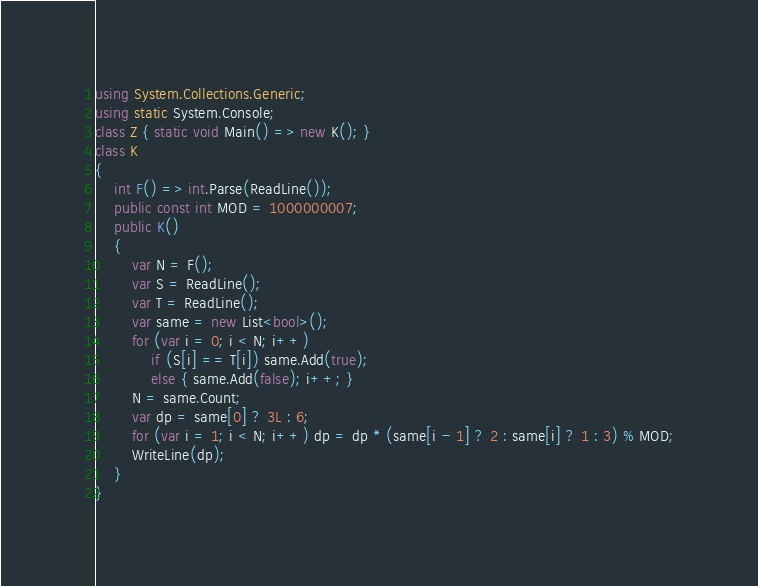<code> <loc_0><loc_0><loc_500><loc_500><_C#_>using System.Collections.Generic;
using static System.Console;
class Z { static void Main() => new K(); }
class K
{
	int F() => int.Parse(ReadLine());
	public const int MOD = 1000000007;
	public K()
	{
		var N = F();
		var S = ReadLine();
		var T = ReadLine();
		var same = new List<bool>();
		for (var i = 0; i < N; i++)
			if (S[i] == T[i]) same.Add(true);
			else { same.Add(false); i++; }
		N = same.Count;
		var dp = same[0] ? 3L : 6;
		for (var i = 1; i < N; i++) dp = dp * (same[i - 1] ? 2 : same[i] ? 1 : 3) % MOD;
		WriteLine(dp);
	}
}
</code> 